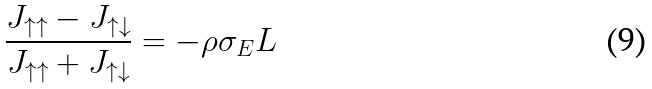<formula> <loc_0><loc_0><loc_500><loc_500>\frac { J _ { \uparrow \uparrow } - J _ { \uparrow \downarrow } } { J _ { \uparrow \uparrow } + J _ { \uparrow \downarrow } } = - \rho \sigma _ { E } L</formula> 